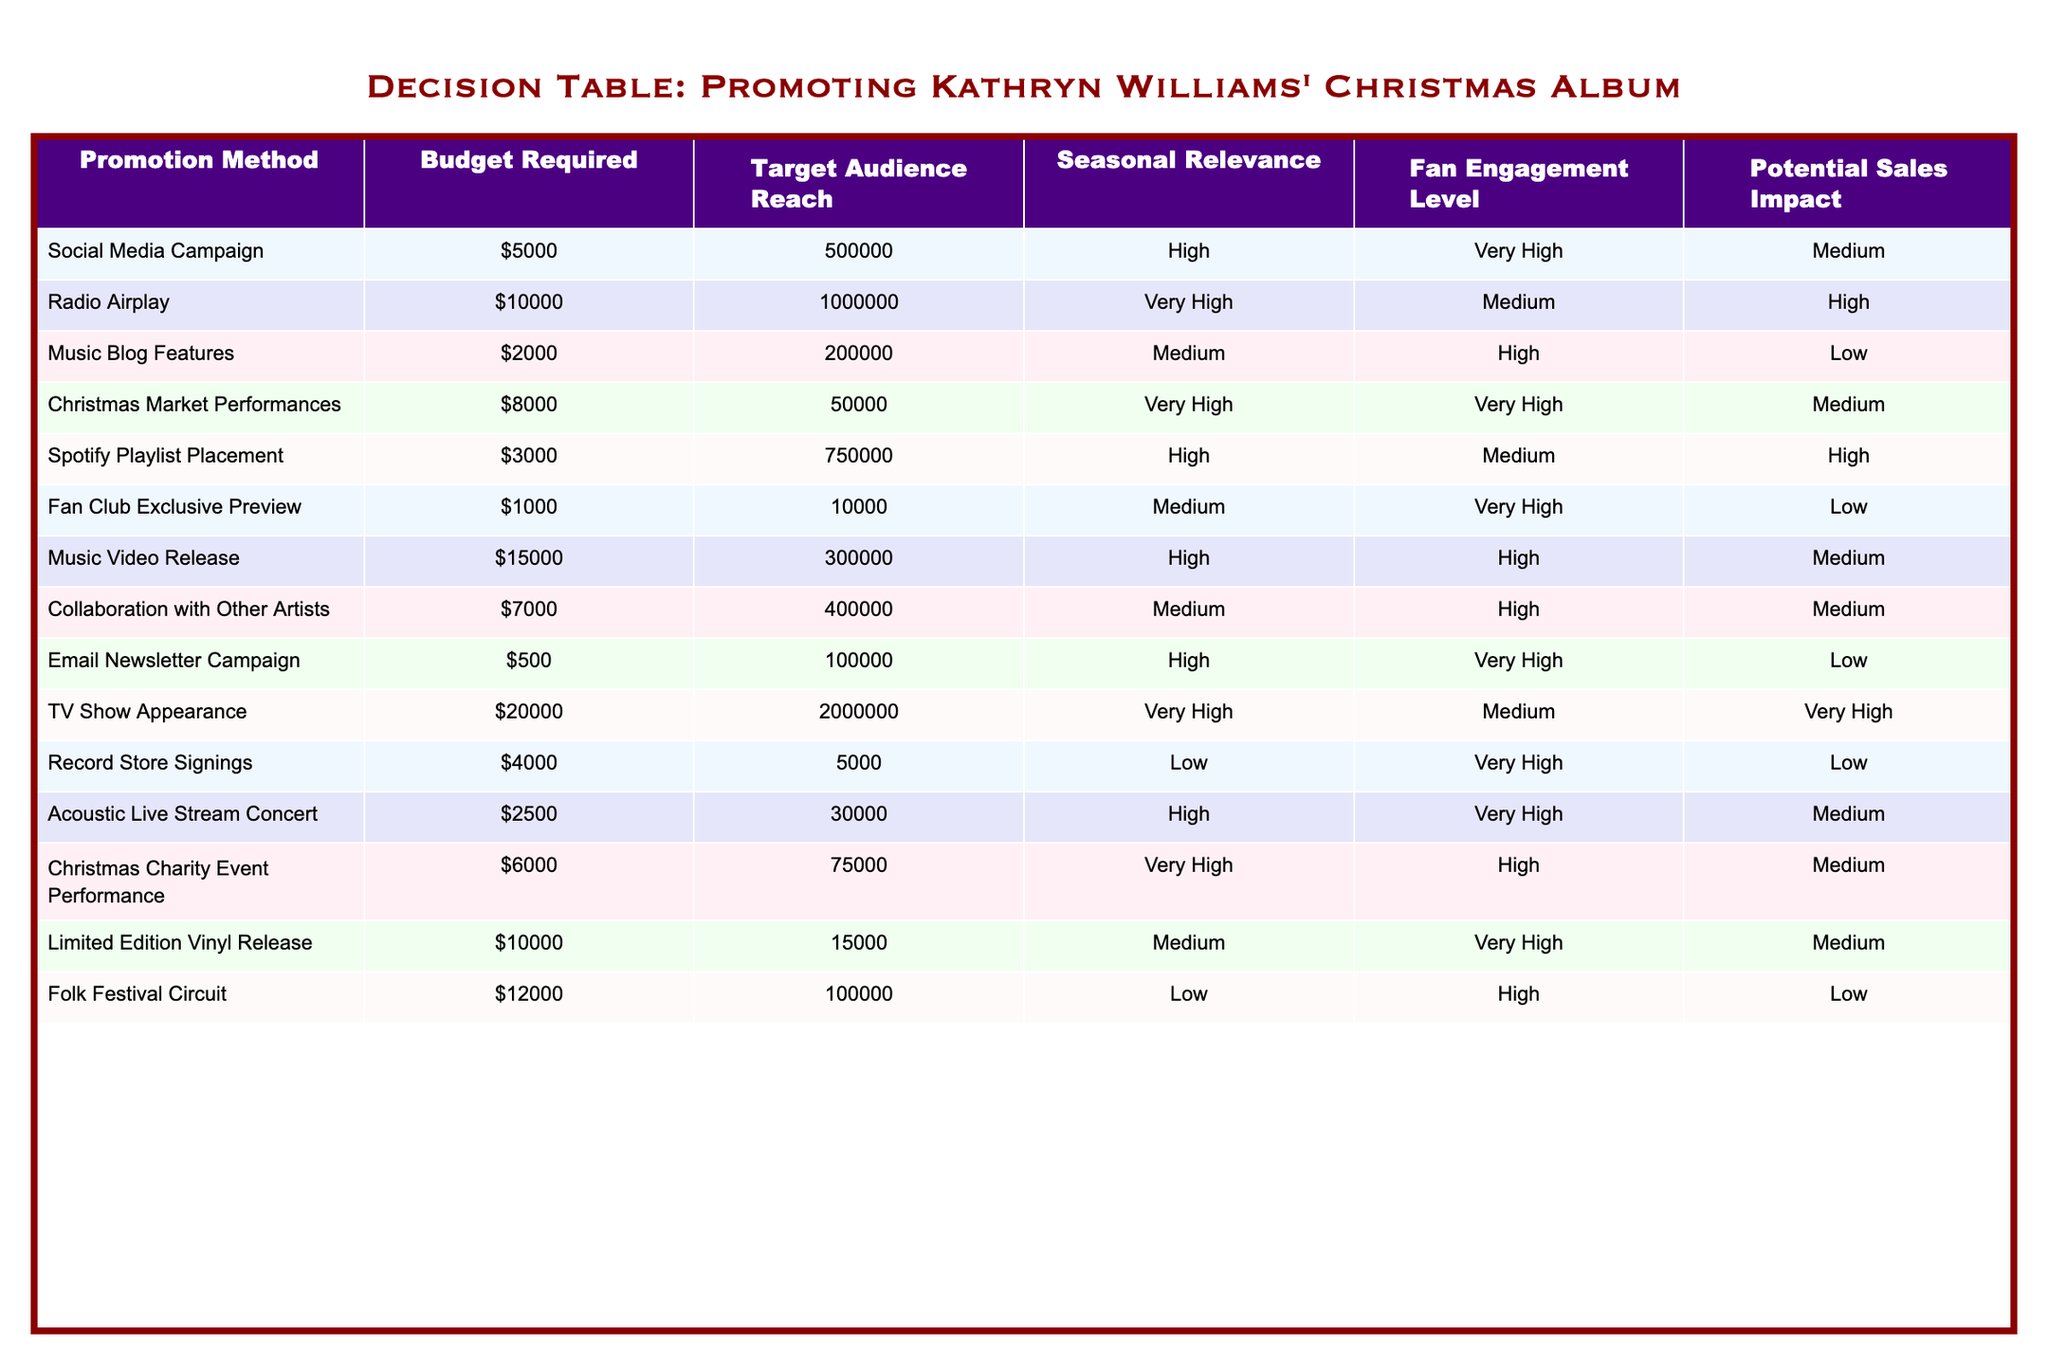What is the budget required for a Christmas market performance? The table shows that the budget required for Christmas Market Performances is $8000.
Answer: $8000 How many audience members can be reached through social media campaigns? According to the table, a Social Media Campaign can reach 500,000 audience members.
Answer: 500,000 Which promotion method has the highest potential sales impact? Looking at the table, Radio Airplay and TV Show Appearance both have a "High" potential sales impact, which is the highest level indicated.
Answer: Radio Airplay and TV Show Appearance What is the total budget required for the top three promotion methods based on target audience reach? The top three based on audience reach are Radio Airplay ($10,000), TV Show Appearance ($20,000), and Social Media Campaign ($5,000). Adding these gives a total of $10,000 + $20,000 + $5,000 = $35,000.
Answer: $35,000 Is the fan engagement level for email newsletter campaigns high? The table indicates that the fan engagement level for Email Newsletter Campaigns is "Very High," which means it is indeed high.
Answer: Yes What is the average budget for the promotion methods with "High" seasonal relevance? The methods with "High" seasonal relevance are Social Media Campaign ($5000), Radio Airplay ($10,000), Spotify Playlist Placement ($3000), and Acoustic Live Stream Concert ($2500). The total budget for these is $5000 + $10000 + $3000 + $2500 = $20500. There are 4 methods, so the average is $20500 / 4 = $5125.
Answer: $5125 How many promotion methods have a "Very High" fan engagement level? Checking the table, the methods with "Very High" fan engagement are Christmas Market Performances, Fan Club Exclusive Preview, Acoustic Live Stream Concert, and Email Newsletter Campaign. This gives a total of 4 methods.
Answer: 4 Which promotion method has the lowest audience reach while retaining a "Very High" fan engagement level? The Record Store Signings method has the lowest audience reach of 5,000 while having a "Very High" fan engagement level according to the table.
Answer: Record Store Signings What is the potential sales impact of the collaboration with other artists? The table shows that the potential sales impact of the Collaboration with Other Artists is classified as "Medium."
Answer: Medium 